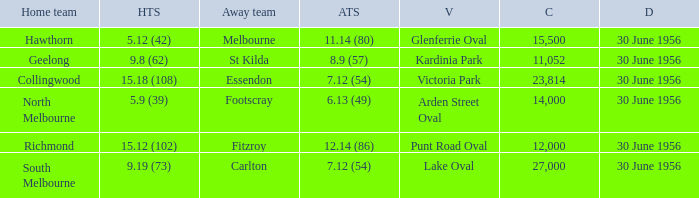What is the home team score when the away team is St Kilda? 9.8 (62). 